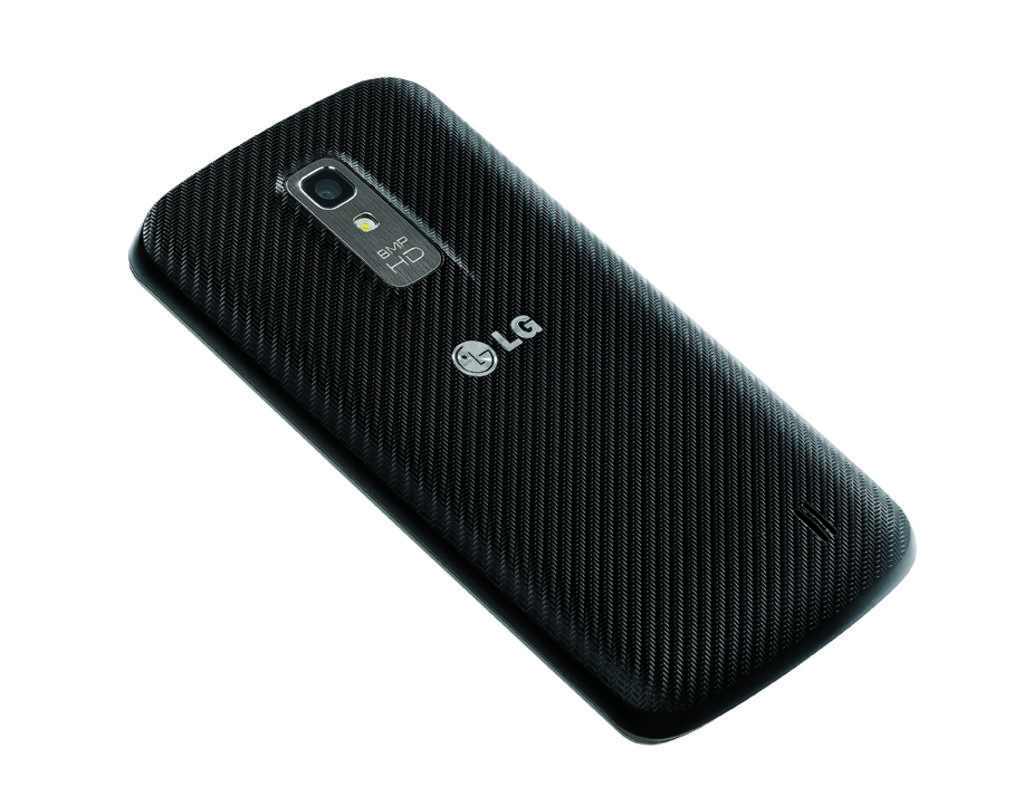In one or two sentences, can you explain what this image depicts? It is a mobile phone which is in black color. 